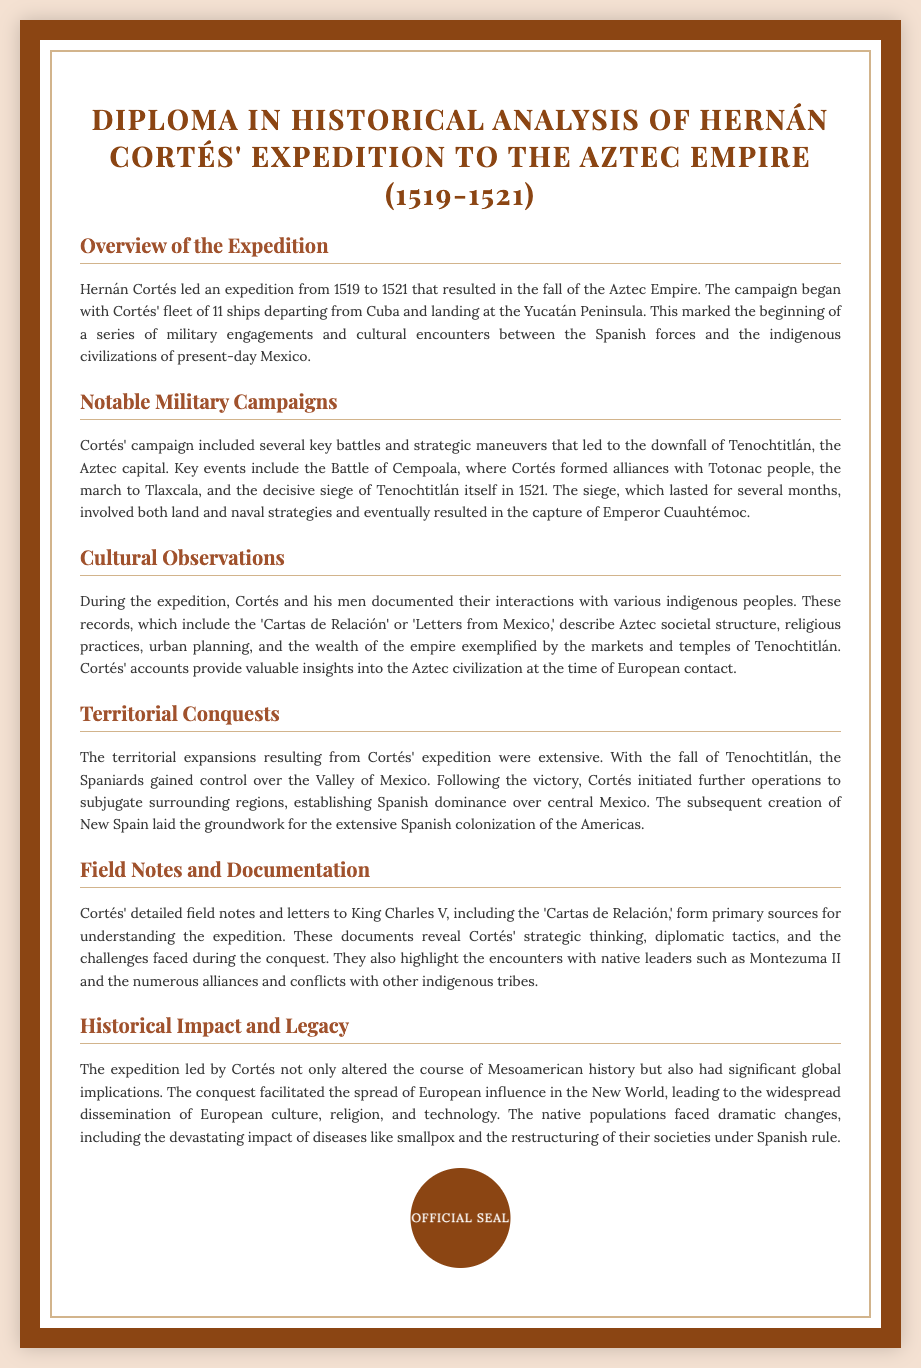What year did Hernán Cortés' expedition begin? The expedition began in 1519.
Answer: 1519 What city was the capital of the Aztec Empire? The capital city of the Aztec Empire was Tenochtitlán.
Answer: Tenochtitlán Who was captured during the siege of Tenochtitlán? The emperor captured during the siege was Cuauhtémoc.
Answer: Cuauhtémoc What document contains Cortés' detailed accounts of his expedition? The detailed accounts are found in the 'Cartas de Relación.'
Answer: Cartas de Relación What was the duration of the siege of Tenochtitlán? The siege lasted several months.
Answer: Several months What was a significant impact of Cortés' expedition on the native populations? A significant impact included the devastating effect of diseases like smallpox.
Answer: Smallpox What civilization did Cortés primarily encounter during his expedition? Cortés primarily encountered the Aztec civilization.
Answer: Aztec What was the name of the initial indigenous people Cortés allied with? The initial allies were the Totonac people.
Answer: Totonac What region did the fall of Tenochtitlán allow the Spaniards to control? The fall allowed control over the Valley of Mexico.
Answer: Valley of Mexico 